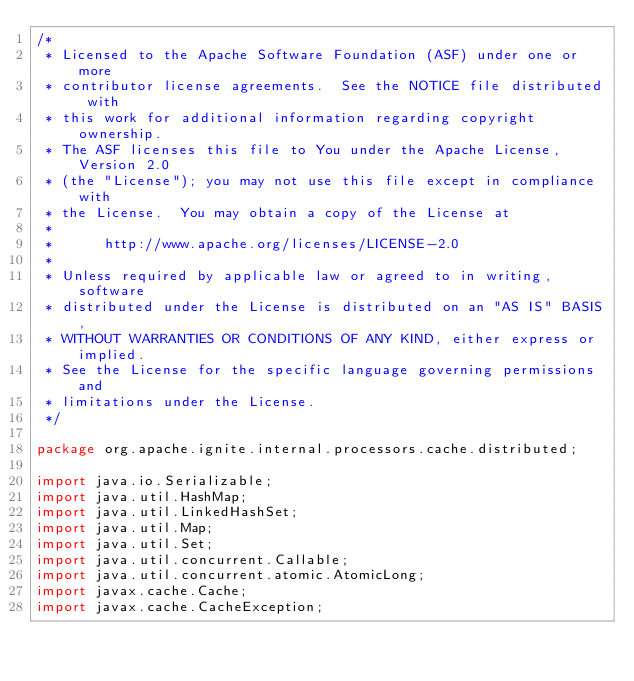<code> <loc_0><loc_0><loc_500><loc_500><_Java_>/*
 * Licensed to the Apache Software Foundation (ASF) under one or more
 * contributor license agreements.  See the NOTICE file distributed with
 * this work for additional information regarding copyright ownership.
 * The ASF licenses this file to You under the Apache License, Version 2.0
 * (the "License"); you may not use this file except in compliance with
 * the License.  You may obtain a copy of the License at
 *
 *      http://www.apache.org/licenses/LICENSE-2.0
 *
 * Unless required by applicable law or agreed to in writing, software
 * distributed under the License is distributed on an "AS IS" BASIS,
 * WITHOUT WARRANTIES OR CONDITIONS OF ANY KIND, either express or implied.
 * See the License for the specific language governing permissions and
 * limitations under the License.
 */

package org.apache.ignite.internal.processors.cache.distributed;

import java.io.Serializable;
import java.util.HashMap;
import java.util.LinkedHashSet;
import java.util.Map;
import java.util.Set;
import java.util.concurrent.Callable;
import java.util.concurrent.atomic.AtomicLong;
import javax.cache.Cache;
import javax.cache.CacheException;</code> 